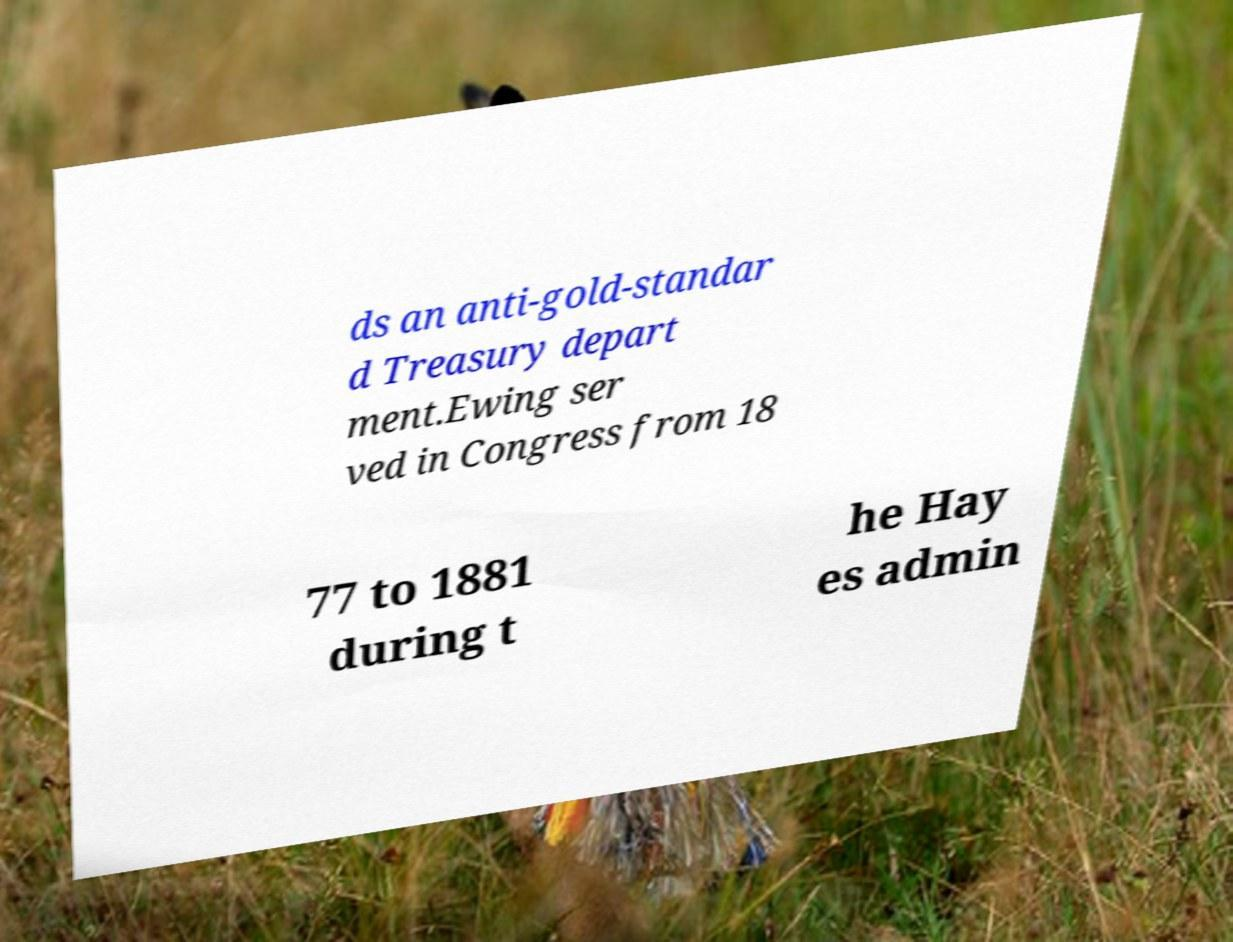I need the written content from this picture converted into text. Can you do that? ds an anti-gold-standar d Treasury depart ment.Ewing ser ved in Congress from 18 77 to 1881 during t he Hay es admin 